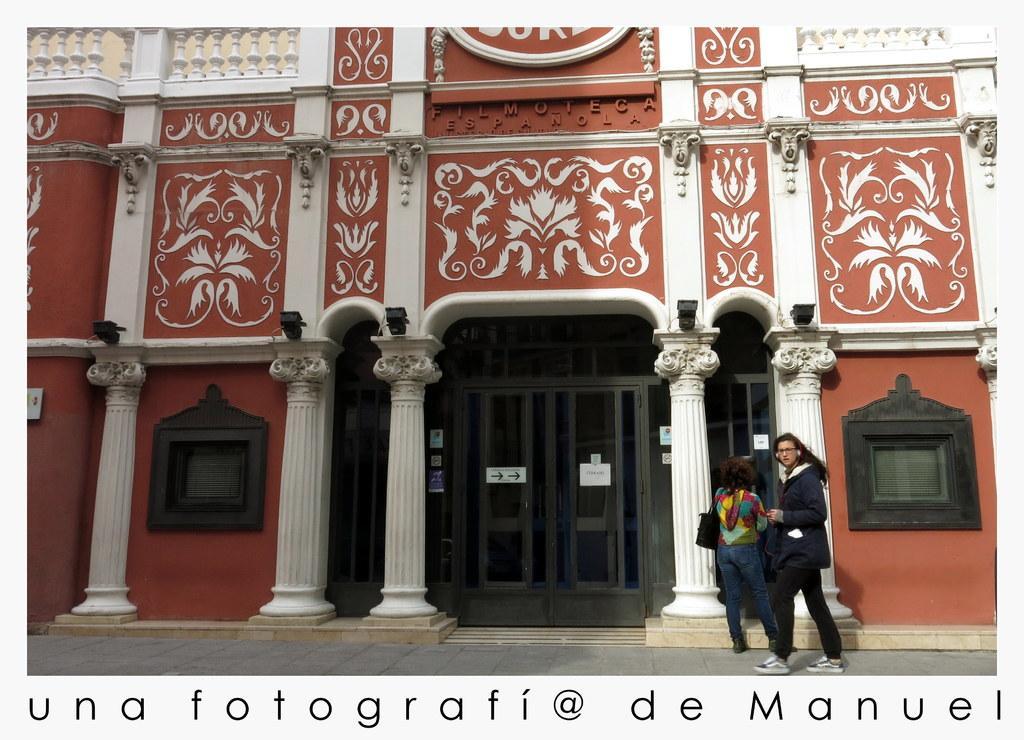Please provide a concise description of this image. In this image, we can see a house with pillars, walls, doors, windows. Here we can see some posters. Right side of the image, we can see two people. Here a person is walking. At the bottom of the image, we can see some text. 